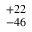<formula> <loc_0><loc_0><loc_500><loc_500>^ { + 2 2 } _ { - 4 6 }</formula> 